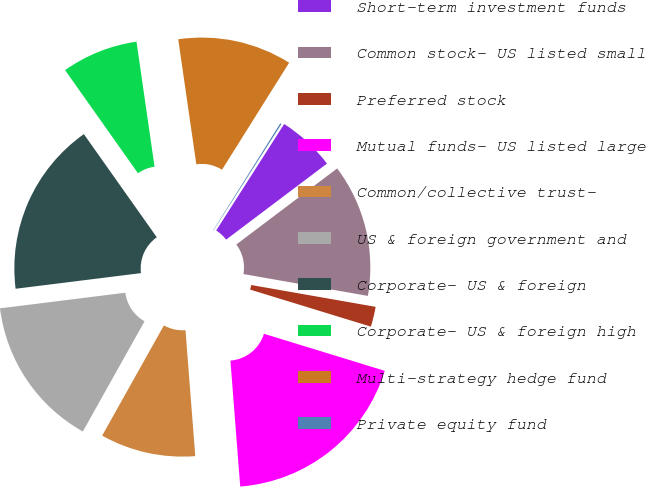Convert chart. <chart><loc_0><loc_0><loc_500><loc_500><pie_chart><fcel>Short-term investment funds<fcel>Common stock- US listed small<fcel>Preferred stock<fcel>Mutual funds- US listed large<fcel>Common/collective trust-<fcel>US & foreign government and<fcel>Corporate- US & foreign<fcel>Corporate- US & foreign high<fcel>Multi-strategy hedge fund<fcel>Private equity fund<nl><fcel>5.67%<fcel>13.05%<fcel>1.97%<fcel>19.03%<fcel>9.36%<fcel>14.9%<fcel>17.18%<fcel>7.51%<fcel>11.2%<fcel>0.13%<nl></chart> 